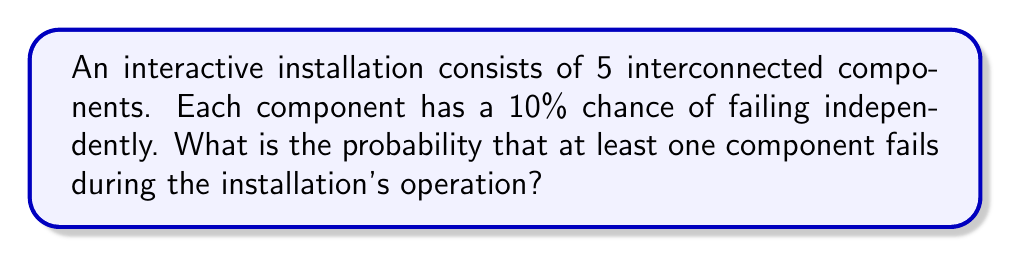Show me your answer to this math problem. Let's approach this step-by-step:

1) First, let's consider the probability of a single component not failing:
   $P(\text{component works}) = 1 - P(\text{component fails}) = 1 - 0.1 = 0.9$ or 90%

2) For the entire installation to work without any failures, all components must work. Since the components are independent, we multiply their individual probabilities:

   $P(\text{all components work}) = 0.9^5 = 0.59049$ or about 59.049%

3) The probability that at least one component fails is the opposite of all components working:

   $P(\text{at least one fails}) = 1 - P(\text{all components work})$
   
   $= 1 - 0.59049 = 0.40951$

4) Convert to a percentage:
   $0.40951 \times 100\% = 40.951\%$

Therefore, the probability that at least one component fails is approximately 40.951%.
Answer: $40.951\%$ 